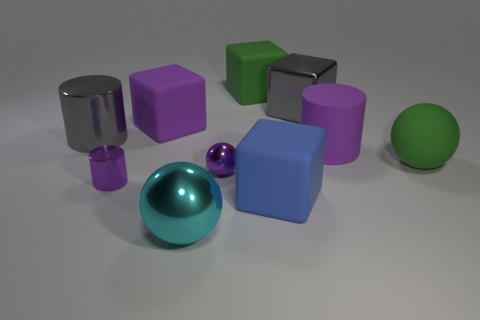Subtract all big purple matte blocks. How many blocks are left? 3 Subtract all purple cylinders. How many cylinders are left? 1 Subtract all spheres. How many objects are left? 7 Subtract all blue balls. Subtract all red blocks. How many balls are left? 3 Subtract all cyan cylinders. How many yellow cubes are left? 0 Subtract all large green metal things. Subtract all small purple metallic spheres. How many objects are left? 9 Add 2 cyan objects. How many cyan objects are left? 3 Add 7 large gray things. How many large gray things exist? 9 Subtract 1 blue blocks. How many objects are left? 9 